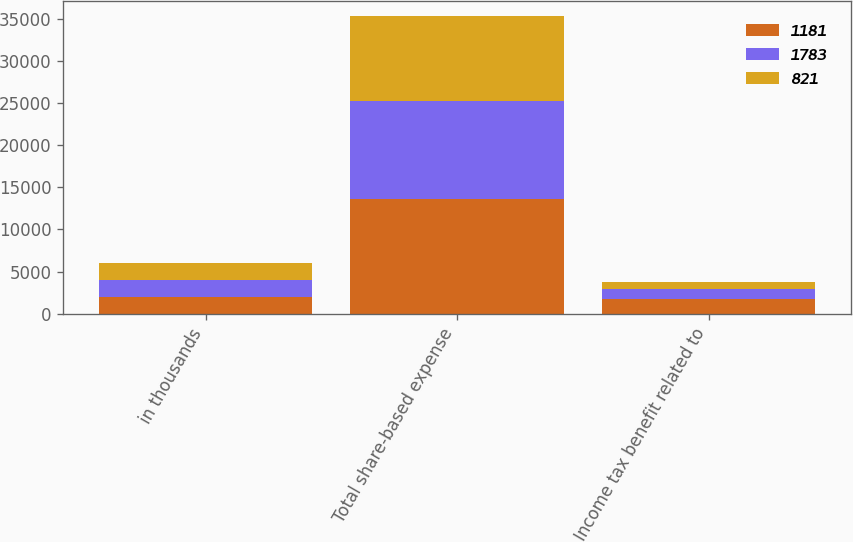Convert chart. <chart><loc_0><loc_0><loc_500><loc_500><stacked_bar_chart><ecel><fcel>in thousands<fcel>Total share-based expense<fcel>Income tax benefit related to<nl><fcel>1181<fcel>2017<fcel>13597<fcel>1783<nl><fcel>1783<fcel>2016<fcel>11648<fcel>1181<nl><fcel>821<fcel>2015<fcel>10196<fcel>821<nl></chart> 